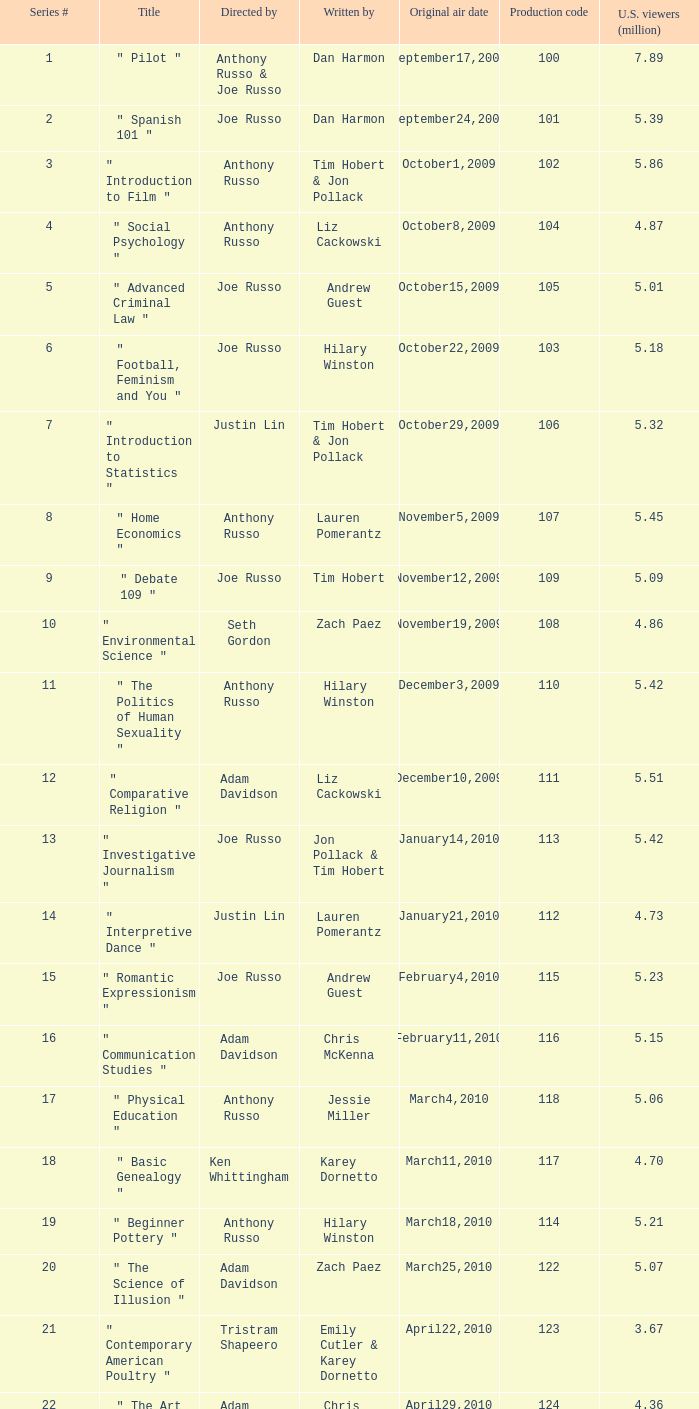39? September24,2009. Can you parse all the data within this table? {'header': ['Series #', 'Title', 'Directed by', 'Written by', 'Original air date', 'Production code', 'U.S. viewers (million)'], 'rows': [['1', '" Pilot "', 'Anthony Russo & Joe Russo', 'Dan Harmon', 'September17,2009', '100', '7.89'], ['2', '" Spanish 101 "', 'Joe Russo', 'Dan Harmon', 'September24,2009', '101', '5.39'], ['3', '" Introduction to Film "', 'Anthony Russo', 'Tim Hobert & Jon Pollack', 'October1,2009', '102', '5.86'], ['4', '" Social Psychology "', 'Anthony Russo', 'Liz Cackowski', 'October8,2009', '104', '4.87'], ['5', '" Advanced Criminal Law "', 'Joe Russo', 'Andrew Guest', 'October15,2009', '105', '5.01'], ['6', '" Football, Feminism and You "', 'Joe Russo', 'Hilary Winston', 'October22,2009', '103', '5.18'], ['7', '" Introduction to Statistics "', 'Justin Lin', 'Tim Hobert & Jon Pollack', 'October29,2009', '106', '5.32'], ['8', '" Home Economics "', 'Anthony Russo', 'Lauren Pomerantz', 'November5,2009', '107', '5.45'], ['9', '" Debate 109 "', 'Joe Russo', 'Tim Hobert', 'November12,2009', '109', '5.09'], ['10', '" Environmental Science "', 'Seth Gordon', 'Zach Paez', 'November19,2009', '108', '4.86'], ['11', '" The Politics of Human Sexuality "', 'Anthony Russo', 'Hilary Winston', 'December3,2009', '110', '5.42'], ['12', '" Comparative Religion "', 'Adam Davidson', 'Liz Cackowski', 'December10,2009', '111', '5.51'], ['13', '" Investigative Journalism "', 'Joe Russo', 'Jon Pollack & Tim Hobert', 'January14,2010', '113', '5.42'], ['14', '" Interpretive Dance "', 'Justin Lin', 'Lauren Pomerantz', 'January21,2010', '112', '4.73'], ['15', '" Romantic Expressionism "', 'Joe Russo', 'Andrew Guest', 'February4,2010', '115', '5.23'], ['16', '" Communication Studies "', 'Adam Davidson', 'Chris McKenna', 'February11,2010', '116', '5.15'], ['17', '" Physical Education "', 'Anthony Russo', 'Jessie Miller', 'March4,2010', '118', '5.06'], ['18', '" Basic Genealogy "', 'Ken Whittingham', 'Karey Dornetto', 'March11,2010', '117', '4.70'], ['19', '" Beginner Pottery "', 'Anthony Russo', 'Hilary Winston', 'March18,2010', '114', '5.21'], ['20', '" The Science of Illusion "', 'Adam Davidson', 'Zach Paez', 'March25,2010', '122', '5.07'], ['21', '" Contemporary American Poultry "', 'Tristram Shapeero', 'Emily Cutler & Karey Dornetto', 'April22,2010', '123', '3.67'], ['22', '" The Art of Discourse "', 'Adam Davidson', 'Chris McKenna', 'April29,2010', '124', '4.36'], ['23', '" Modern Warfare "', 'Justin Lin', 'Emily Cutler', 'May6,2010', '119', '4.35'], ['24', '" English as a Second Language "', 'Gail Mancuso', 'Tim Hobert', 'May13,2010', '120', '4.49']]} 